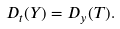Convert formula to latex. <formula><loc_0><loc_0><loc_500><loc_500>D _ { t } ( Y ) = D _ { y } ( T ) .</formula> 